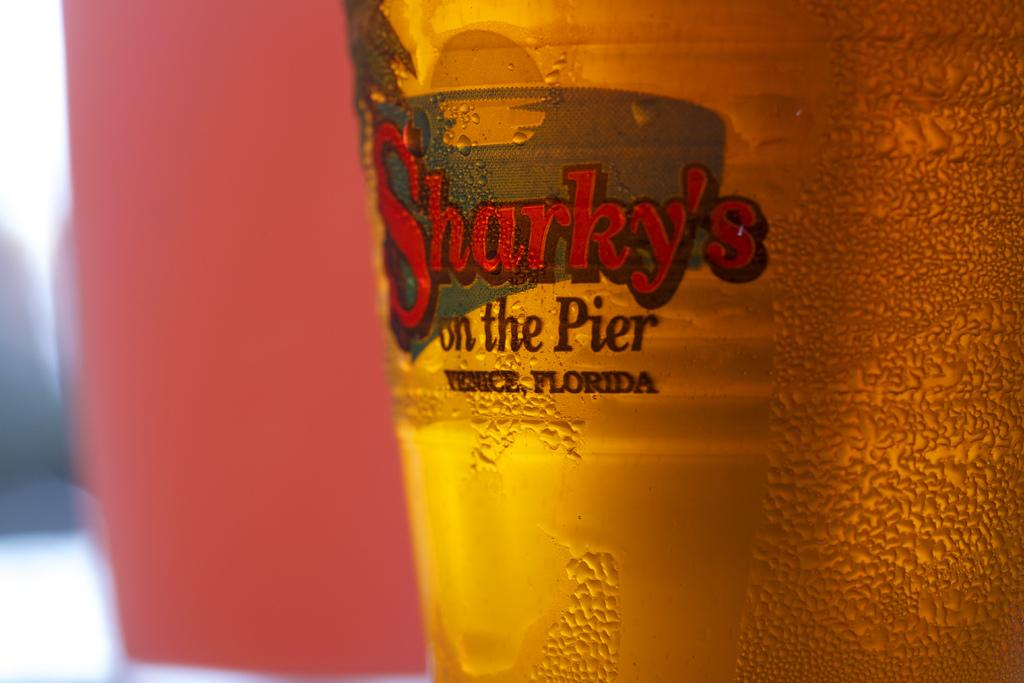<image>
Provide a brief description of the given image. A cup of beer reads "Sharky's on the Pier". 